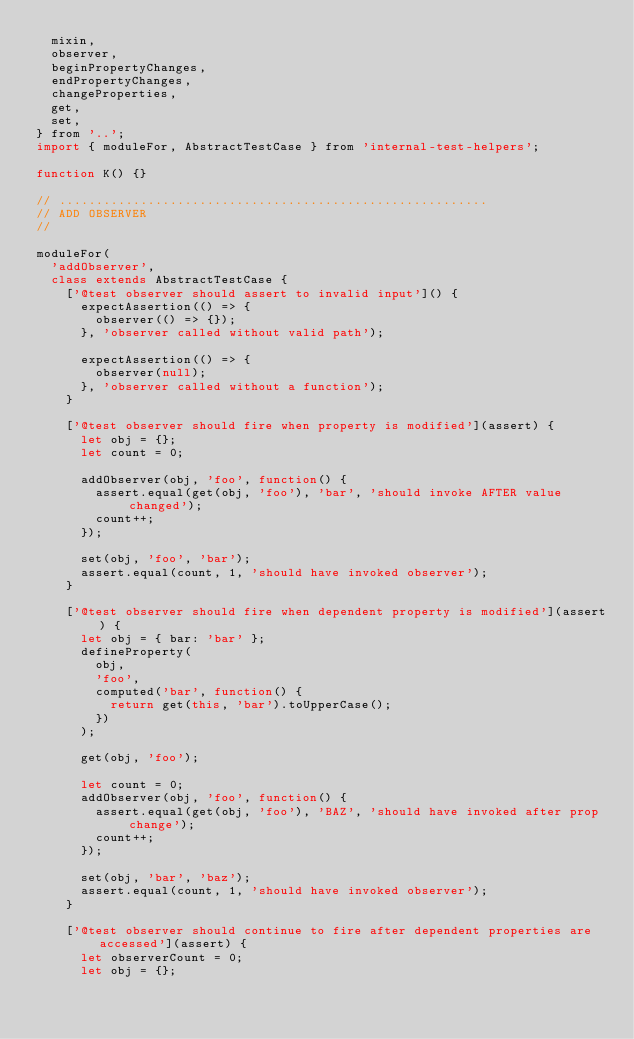Convert code to text. <code><loc_0><loc_0><loc_500><loc_500><_JavaScript_>  mixin,
  observer,
  beginPropertyChanges,
  endPropertyChanges,
  changeProperties,
  get,
  set,
} from '..';
import { moduleFor, AbstractTestCase } from 'internal-test-helpers';

function K() {}

// ..........................................................
// ADD OBSERVER
//

moduleFor(
  'addObserver',
  class extends AbstractTestCase {
    ['@test observer should assert to invalid input']() {
      expectAssertion(() => {
        observer(() => {});
      }, 'observer called without valid path');

      expectAssertion(() => {
        observer(null);
      }, 'observer called without a function');
    }

    ['@test observer should fire when property is modified'](assert) {
      let obj = {};
      let count = 0;

      addObserver(obj, 'foo', function() {
        assert.equal(get(obj, 'foo'), 'bar', 'should invoke AFTER value changed');
        count++;
      });

      set(obj, 'foo', 'bar');
      assert.equal(count, 1, 'should have invoked observer');
    }

    ['@test observer should fire when dependent property is modified'](assert) {
      let obj = { bar: 'bar' };
      defineProperty(
        obj,
        'foo',
        computed('bar', function() {
          return get(this, 'bar').toUpperCase();
        })
      );

      get(obj, 'foo');

      let count = 0;
      addObserver(obj, 'foo', function() {
        assert.equal(get(obj, 'foo'), 'BAZ', 'should have invoked after prop change');
        count++;
      });

      set(obj, 'bar', 'baz');
      assert.equal(count, 1, 'should have invoked observer');
    }

    ['@test observer should continue to fire after dependent properties are accessed'](assert) {
      let observerCount = 0;
      let obj = {};
</code> 